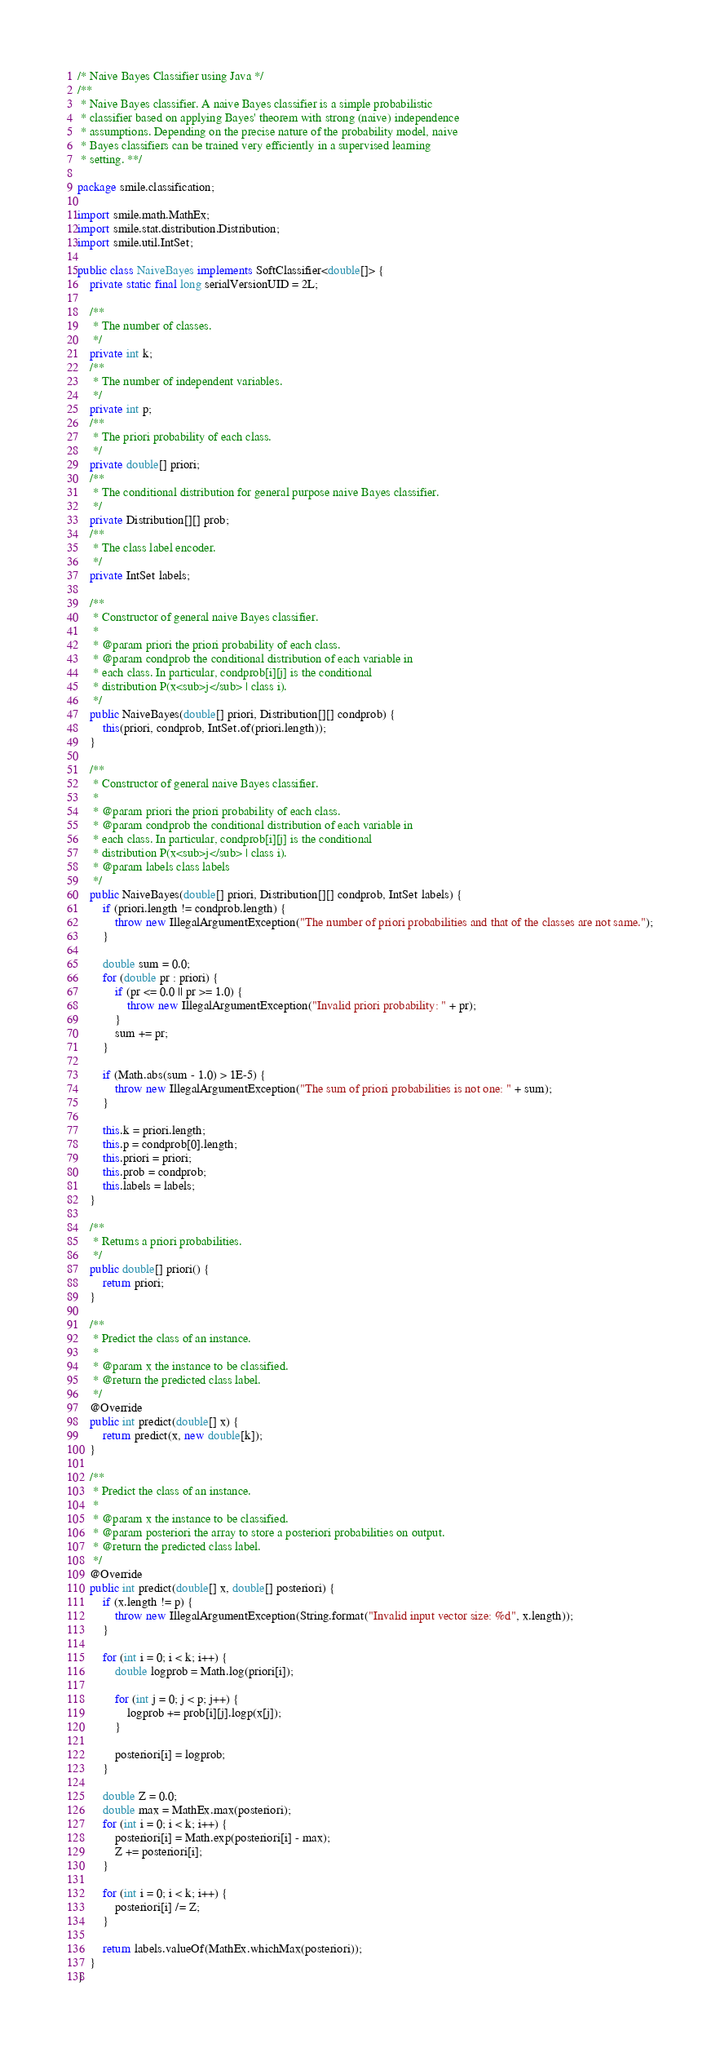<code> <loc_0><loc_0><loc_500><loc_500><_Java_>/* Naive Bayes Classifier using Java */
/**
 * Naive Bayes classifier. A naive Bayes classifier is a simple probabilistic
 * classifier based on applying Bayes' theorem with strong (naive) independence
 * assumptions. Depending on the precise nature of the probability model, naive
 * Bayes classifiers can be trained very efficiently in a supervised learning
 * setting. **/

package smile.classification;

import smile.math.MathEx;
import smile.stat.distribution.Distribution;
import smile.util.IntSet;

public class NaiveBayes implements SoftClassifier<double[]> {
    private static final long serialVersionUID = 2L;

    /**
     * The number of classes.
     */
    private int k;
    /**
     * The number of independent variables.
     */
    private int p;
    /**
     * The priori probability of each class.
     */
    private double[] priori;
    /**
     * The conditional distribution for general purpose naive Bayes classifier.
     */
    private Distribution[][] prob;
    /**
     * The class label encoder.
     */
    private IntSet labels;

    /**
     * Constructor of general naive Bayes classifier.
     *
     * @param priori the priori probability of each class.
     * @param condprob the conditional distribution of each variable in
     * each class. In particular, condprob[i][j] is the conditional
     * distribution P(x<sub>j</sub> | class i).
     */
    public NaiveBayes(double[] priori, Distribution[][] condprob) {
        this(priori, condprob, IntSet.of(priori.length));
    }

    /**
     * Constructor of general naive Bayes classifier.
     * 
     * @param priori the priori probability of each class.
     * @param condprob the conditional distribution of each variable in
     * each class. In particular, condprob[i][j] is the conditional
     * distribution P(x<sub>j</sub> | class i).
     * @param labels class labels
     */
    public NaiveBayes(double[] priori, Distribution[][] condprob, IntSet labels) {
        if (priori.length != condprob.length) {
            throw new IllegalArgumentException("The number of priori probabilities and that of the classes are not same.");
        }

        double sum = 0.0;
        for (double pr : priori) {
            if (pr <= 0.0 || pr >= 1.0) {
                throw new IllegalArgumentException("Invalid priori probability: " + pr);
            }
            sum += pr;
        }

        if (Math.abs(sum - 1.0) > 1E-5) {
            throw new IllegalArgumentException("The sum of priori probabilities is not one: " + sum);
        }

        this.k = priori.length;
        this.p = condprob[0].length;
        this.priori = priori;
        this.prob = condprob;
        this.labels = labels;
    }

    /**
     * Returns a priori probabilities.
     */
    public double[] priori() {
        return priori;
    }

    /**
     * Predict the class of an instance.
     * 
     * @param x the instance to be classified.
     * @return the predicted class label.
     */
    @Override
    public int predict(double[] x) {
        return predict(x, new double[k]);
    }

    /**
     * Predict the class of an instance.
     * 
     * @param x the instance to be classified.
     * @param posteriori the array to store a posteriori probabilities on output.
     * @return the predicted class label.
     */
    @Override
    public int predict(double[] x, double[] posteriori) {
        if (x.length != p) {
            throw new IllegalArgumentException(String.format("Invalid input vector size: %d", x.length));
        }

        for (int i = 0; i < k; i++) {
            double logprob = Math.log(priori[i]);

            for (int j = 0; j < p; j++) {
                logprob += prob[i][j].logp(x[j]);
            }

            posteriori[i] = logprob;
        }

        double Z = 0.0;
        double max = MathEx.max(posteriori);
        for (int i = 0; i < k; i++) {
            posteriori[i] = Math.exp(posteriori[i] - max);
            Z += posteriori[i];
        }

        for (int i = 0; i < k; i++) {
            posteriori[i] /= Z;
        }

        return labels.valueOf(MathEx.whichMax(posteriori));
    }
}
</code> 